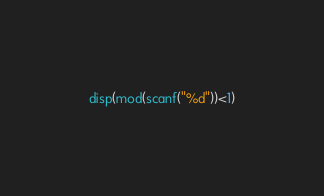Convert code to text. <code><loc_0><loc_0><loc_500><loc_500><_Octave_>disp(mod(scanf("%d"))<1)</code> 